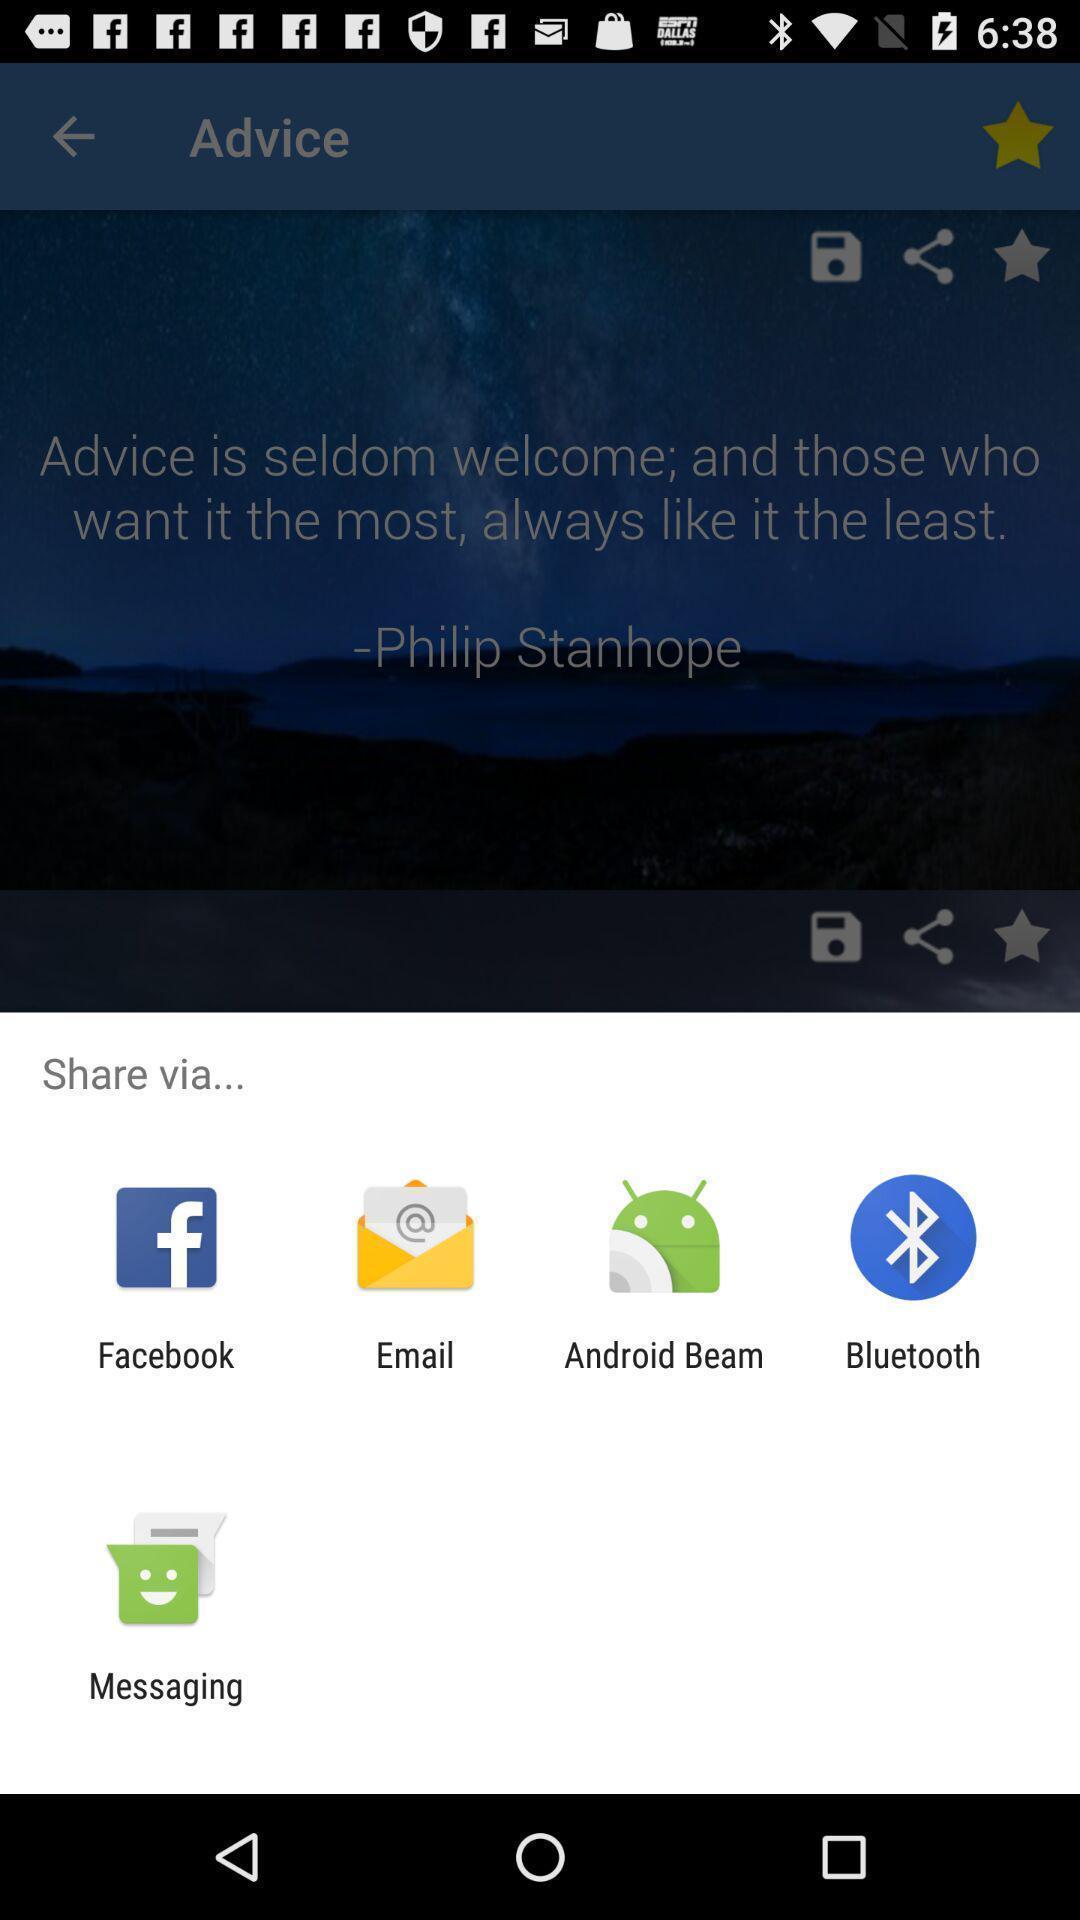Describe the key features of this screenshot. Quote of advice share through different applications. 